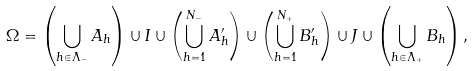<formula> <loc_0><loc_0><loc_500><loc_500>\Omega = \left ( \bigcup _ { h \in \Lambda _ { - } } A _ { h } \right ) \cup I \cup \left ( \bigcup _ { h = 1 } ^ { N _ { - } } A ^ { \prime } _ { h } \right ) \cup \left ( \bigcup _ { h = 1 } ^ { N _ { + } } B ^ { \prime } _ { h } \right ) \cup J \cup \left ( \bigcup _ { h \in \Lambda _ { + } } B _ { h } \right ) ,</formula> 